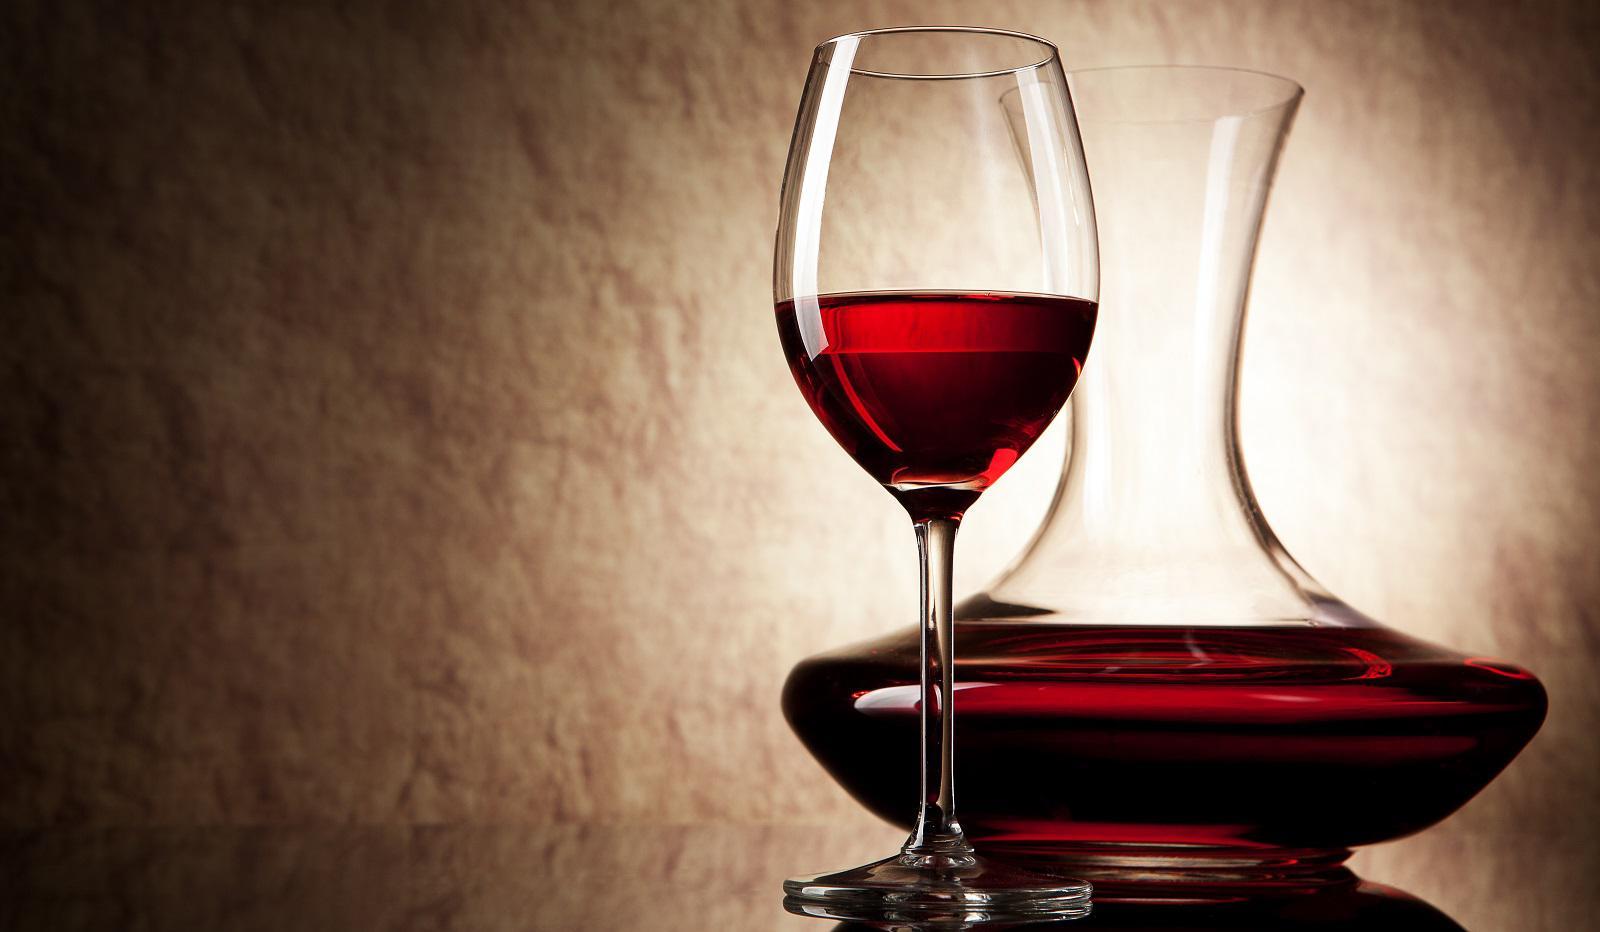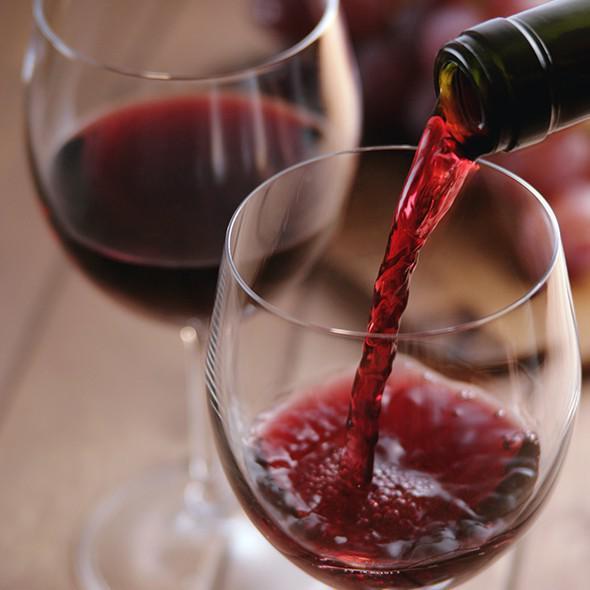The first image is the image on the left, the second image is the image on the right. For the images displayed, is the sentence "Wine is pouring from a bottle into a glass in the right image." factually correct? Answer yes or no. Yes. 